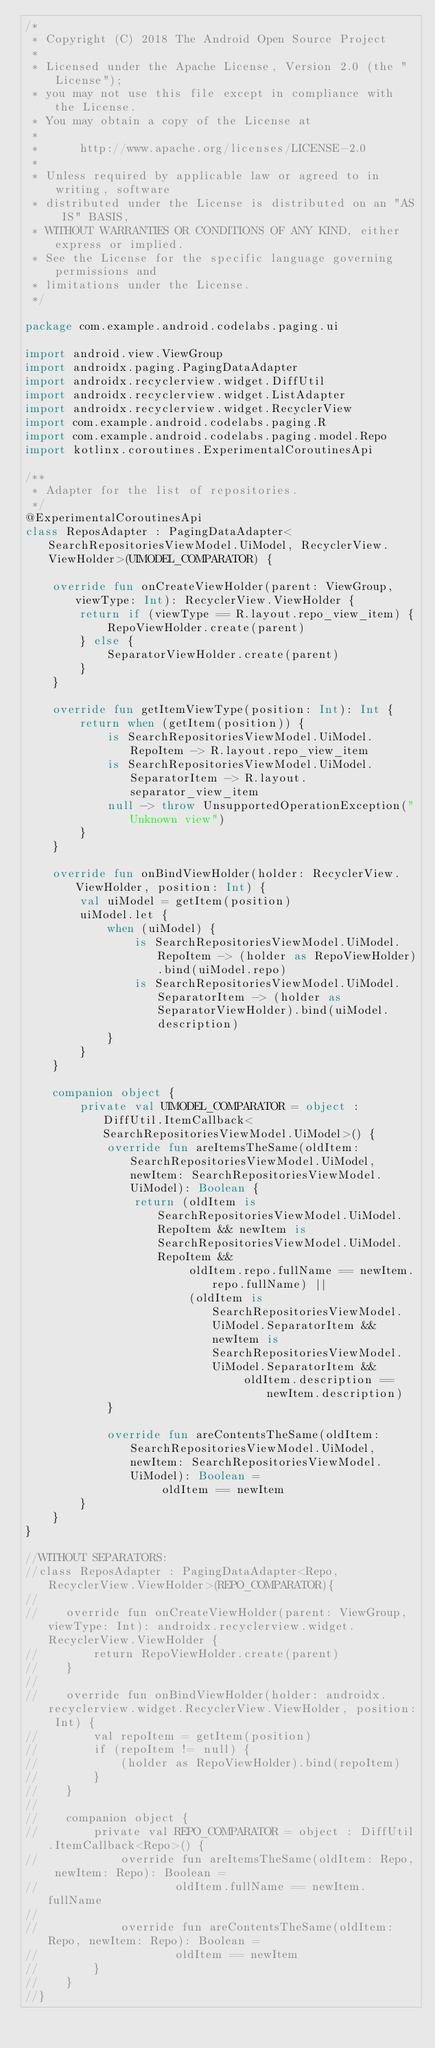Convert code to text. <code><loc_0><loc_0><loc_500><loc_500><_Kotlin_>/*
 * Copyright (C) 2018 The Android Open Source Project
 *
 * Licensed under the Apache License, Version 2.0 (the "License");
 * you may not use this file except in compliance with the License.
 * You may obtain a copy of the License at
 *
 *      http://www.apache.org/licenses/LICENSE-2.0
 *
 * Unless required by applicable law or agreed to in writing, software
 * distributed under the License is distributed on an "AS IS" BASIS,
 * WITHOUT WARRANTIES OR CONDITIONS OF ANY KIND, either express or implied.
 * See the License for the specific language governing permissions and
 * limitations under the License.
 */

package com.example.android.codelabs.paging.ui

import android.view.ViewGroup
import androidx.paging.PagingDataAdapter
import androidx.recyclerview.widget.DiffUtil
import androidx.recyclerview.widget.ListAdapter
import androidx.recyclerview.widget.RecyclerView
import com.example.android.codelabs.paging.R
import com.example.android.codelabs.paging.model.Repo
import kotlinx.coroutines.ExperimentalCoroutinesApi

/**
 * Adapter for the list of repositories.
 */
@ExperimentalCoroutinesApi
class ReposAdapter : PagingDataAdapter<SearchRepositoriesViewModel.UiModel, RecyclerView.ViewHolder>(UIMODEL_COMPARATOR) {

    override fun onCreateViewHolder(parent: ViewGroup, viewType: Int): RecyclerView.ViewHolder {
        return if (viewType == R.layout.repo_view_item) {
            RepoViewHolder.create(parent)
        } else {
            SeparatorViewHolder.create(parent)
        }
    }

    override fun getItemViewType(position: Int): Int {
        return when (getItem(position)) {
            is SearchRepositoriesViewModel.UiModel.RepoItem -> R.layout.repo_view_item
            is SearchRepositoriesViewModel.UiModel.SeparatorItem -> R.layout.separator_view_item
            null -> throw UnsupportedOperationException("Unknown view")
        }
    }

    override fun onBindViewHolder(holder: RecyclerView.ViewHolder, position: Int) {
        val uiModel = getItem(position)
        uiModel.let {
            when (uiModel) {
                is SearchRepositoriesViewModel.UiModel.RepoItem -> (holder as RepoViewHolder).bind(uiModel.repo)
                is SearchRepositoriesViewModel.UiModel.SeparatorItem -> (holder as SeparatorViewHolder).bind(uiModel.description)
            }
        }
    }

    companion object {
        private val UIMODEL_COMPARATOR = object : DiffUtil.ItemCallback<SearchRepositoriesViewModel.UiModel>() {
            override fun areItemsTheSame(oldItem: SearchRepositoriesViewModel.UiModel, newItem: SearchRepositoriesViewModel.UiModel): Boolean {
                return (oldItem is SearchRepositoriesViewModel.UiModel.RepoItem && newItem is SearchRepositoriesViewModel.UiModel.RepoItem &&
                        oldItem.repo.fullName == newItem.repo.fullName) ||
                        (oldItem is SearchRepositoriesViewModel.UiModel.SeparatorItem && newItem is SearchRepositoriesViewModel.UiModel.SeparatorItem &&
                                oldItem.description == newItem.description)
            }

            override fun areContentsTheSame(oldItem: SearchRepositoriesViewModel.UiModel, newItem: SearchRepositoriesViewModel.UiModel): Boolean =
                    oldItem == newItem
        }
    }
}

//WITHOUT SEPARATORS:
//class ReposAdapter : PagingDataAdapter<Repo, RecyclerView.ViewHolder>(REPO_COMPARATOR){
//
//    override fun onCreateViewHolder(parent: ViewGroup, viewType: Int): androidx.recyclerview.widget.RecyclerView.ViewHolder {
//        return RepoViewHolder.create(parent)
//    }
//
//    override fun onBindViewHolder(holder: androidx.recyclerview.widget.RecyclerView.ViewHolder, position: Int) {
//        val repoItem = getItem(position)
//        if (repoItem != null) {
//            (holder as RepoViewHolder).bind(repoItem)
//        }
//    }
//
//    companion object {
//        private val REPO_COMPARATOR = object : DiffUtil.ItemCallback<Repo>() {
//            override fun areItemsTheSame(oldItem: Repo, newItem: Repo): Boolean =
//                    oldItem.fullName == newItem.fullName
//
//            override fun areContentsTheSame(oldItem: Repo, newItem: Repo): Boolean =
//                    oldItem == newItem
//        }
//    }
//}
</code> 